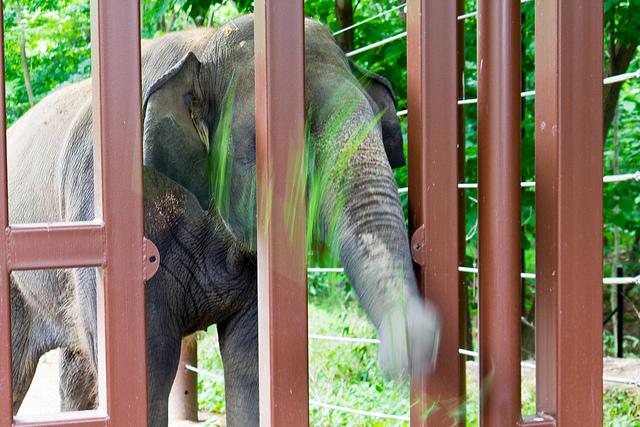Is this a mature elephant?
Concise answer only. Yes. Is there a fence?
Concise answer only. Yes. Is this animal contained?
Short answer required. Yes. 